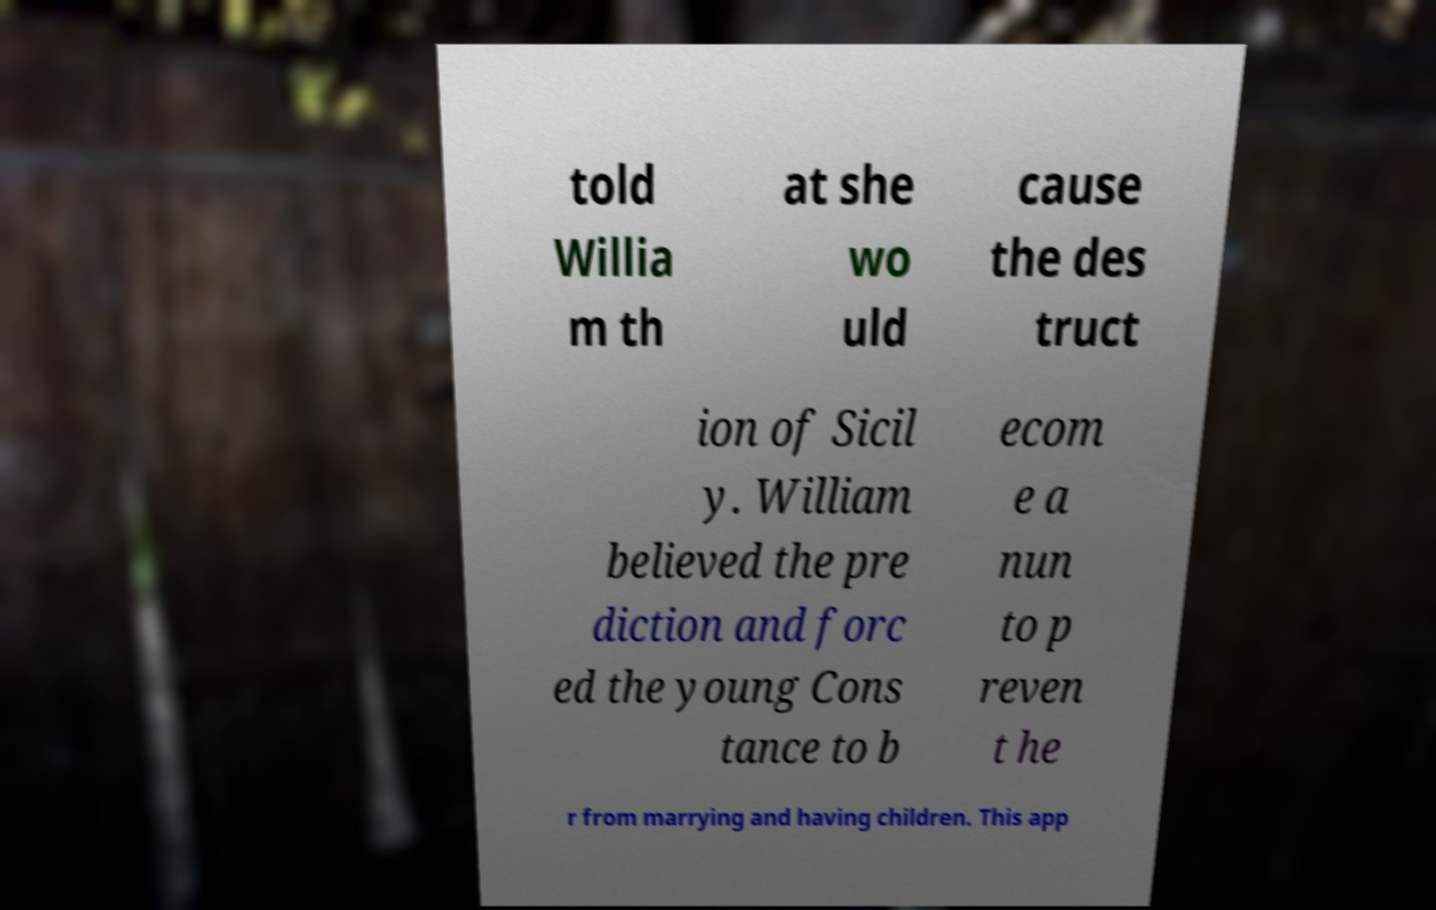What messages or text are displayed in this image? I need them in a readable, typed format. told Willia m th at she wo uld cause the des truct ion of Sicil y. William believed the pre diction and forc ed the young Cons tance to b ecom e a nun to p reven t he r from marrying and having children. This app 